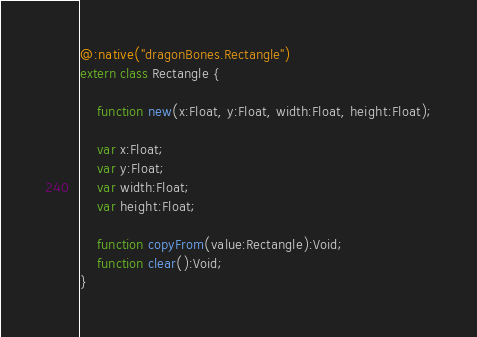Convert code to text. <code><loc_0><loc_0><loc_500><loc_500><_Haxe_>
@:native("dragonBones.Rectangle")
extern class Rectangle {

	function new(x:Float, y:Float, width:Float, height:Float);

	var x:Float;
	var y:Float;
	var width:Float;
	var height:Float;

	function copyFrom(value:Rectangle):Void;
	function clear():Void;
}</code> 